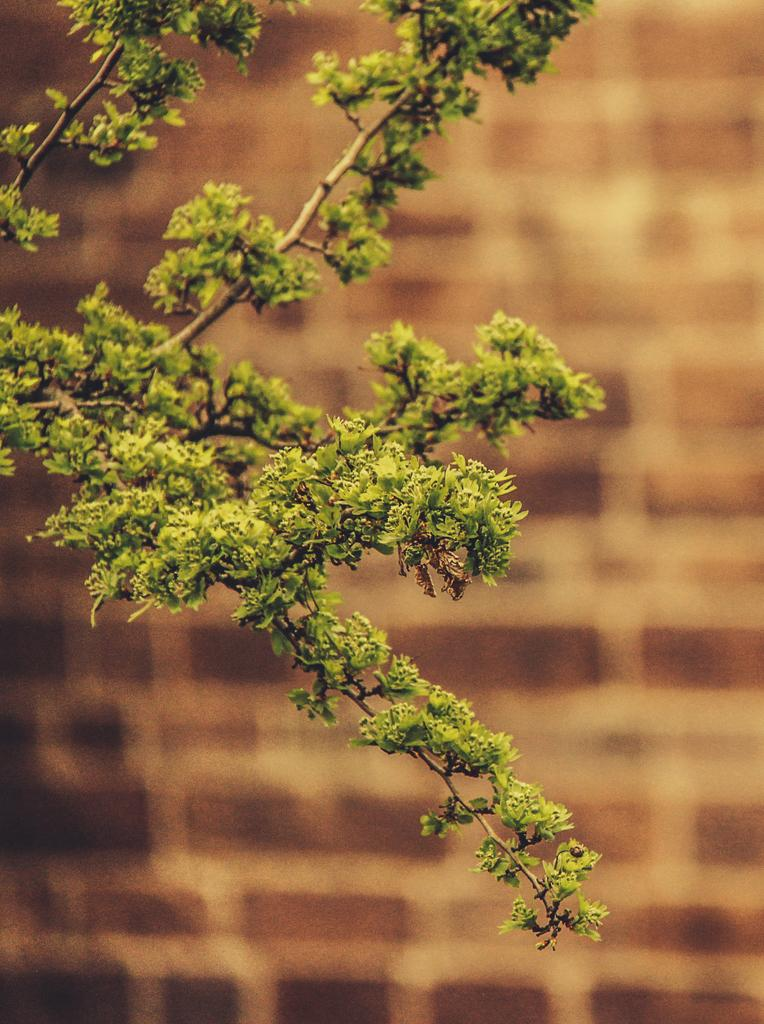What is located in front of the image? There is a tree in front of the image. What can be seen in the background of the image? There is a wall in the background of the image. How does the tree increase in size in the image? The tree does not increase in size in the image; it is a static image. What type of plot is being depicted in the image? There is no specific plot being depicted in the image; it simply shows a tree in front of a wall. 